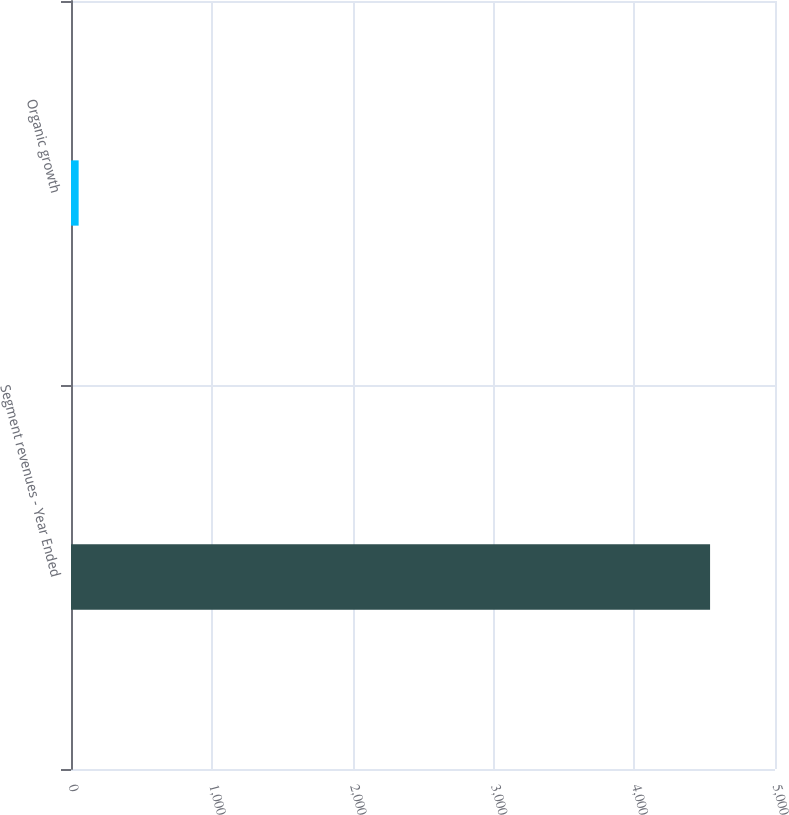<chart> <loc_0><loc_0><loc_500><loc_500><bar_chart><fcel>Segment revenues - Year Ended<fcel>Organic growth<nl><fcel>4538.87<fcel>54.3<nl></chart> 